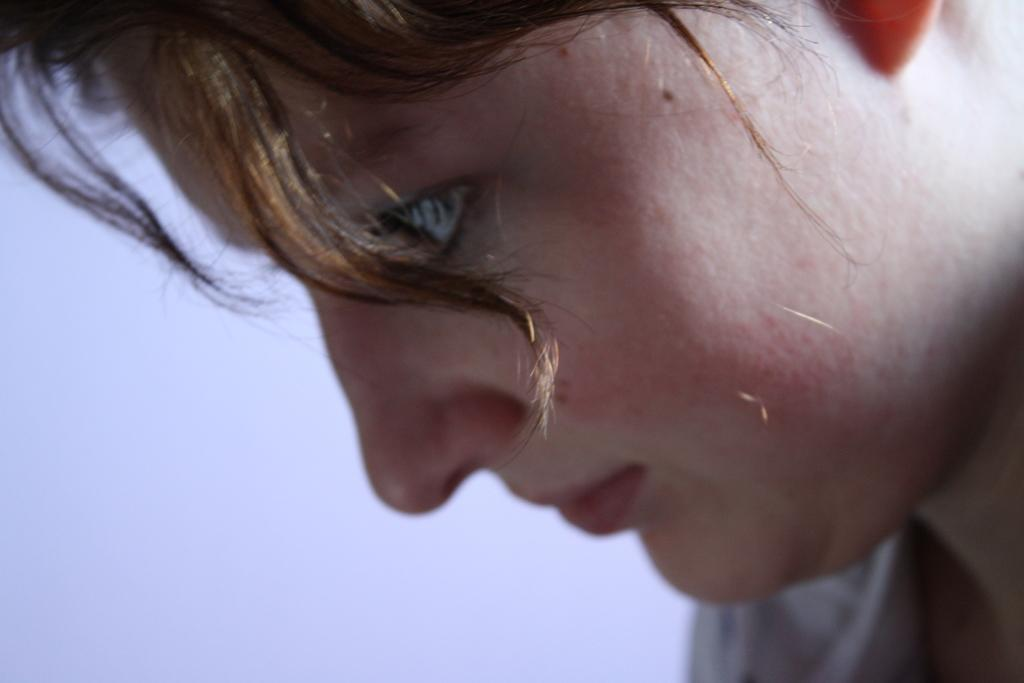What is the main subject of the image? There is a person in the image. Can you describe the person's facial features? The person has hair on their face. What color is the background of the image? The background of the image is white. What type of pain is the person experiencing in the image? There is no indication of pain in the image; the person's facial expression is not visible. 